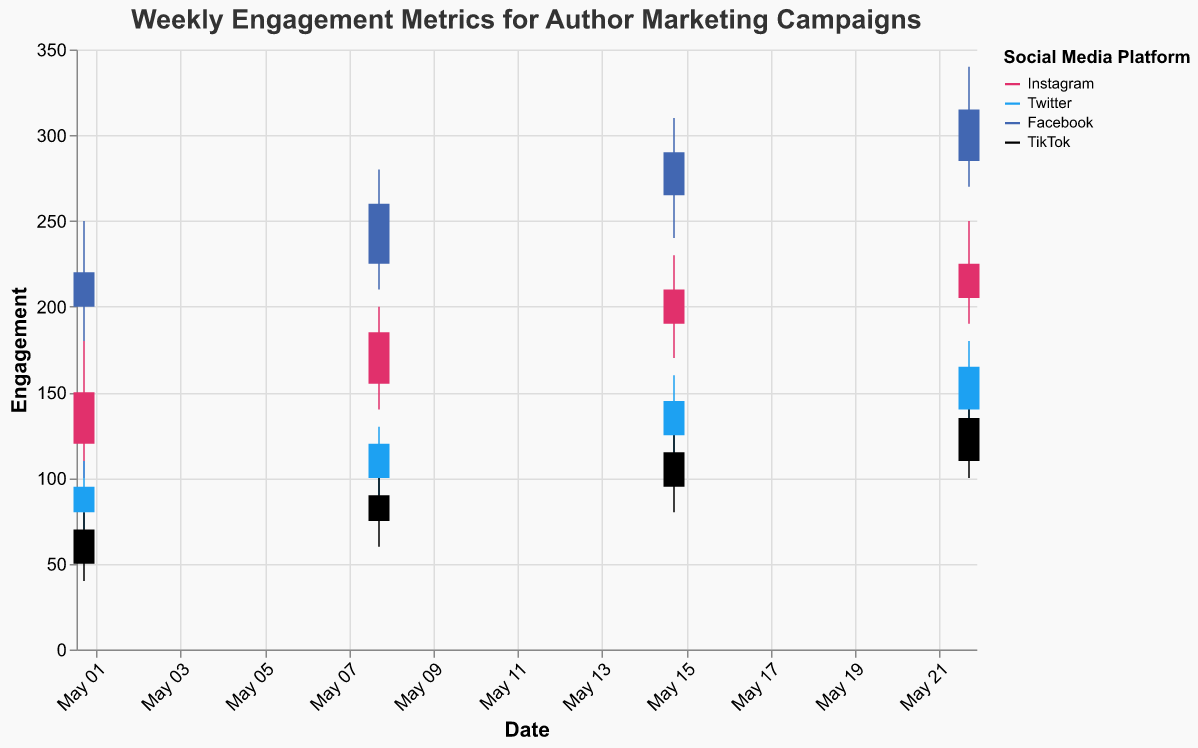What's the engagement range on Instagram for the week of May 8, 2023? To find the engagement range, subtract the Low value from the High value for the specified week. Here, the High value is 200 and the Low value is 140. So, 200 - 140 = 60.
Answer: 60 Which social media platform had the highest engagement on May 22, 2023? Look for the highest High value on May 22, 2023. The High values for Instagram, Twitter, Facebook, and TikTok are 250, 180, 340, and 150 respectively. Facebook has the highest value at 340.
Answer: Facebook What was the closing engagement on Twitter on May 15, 2023? Locate the Close value for Twitter on May 15, 2023. The Close value is 145.
Answer: 145 Which week shows the highest increase in closing engagement for Instagram? Calculate the difference in Close values week by week for Instagram. The differences are: (185-150) = 35, (210-185) = 25, (225-210) = 15. The highest increase is from 150 to 185 (35).
Answer: May 8, 2023 Compare the engagement trends between Instagram and TikTok. Which platform had a more consistent increase? Evaluate the Open and Close values across the weeks for both platforms. Instagram's Close values increase consistently each week (150, 185, 210, 225), while TikTok's Close values also increase consistently though with smaller increments (70, 90, 115, 135). Both platforms show consistent increases, but Instagram's increments are larger.
Answer: Instagram Which platform had the lowest opening engagement on May 1, 2023? Look for the lowest Open value among the platforms on May 1, 2023. The Open values are Instagram 120, Twitter 80, Facebook 200, TikTok 50. TikTok has the lowest value at 50.
Answer: TikTok For the week of May 15, 2023, which platform had the highest volatility in engagement? Volatility can be calculated as (High - Low). For May 15, 2023, Instagram: (230-170)=60, Twitter: (160-110)=50, Facebook: (310-240)=70, TikTok: (130-80)=50. Facebook had the highest volatility at 70.
Answer: Facebook What is the overall trend in the engagement for Facebook throughout May 2023? Observe the High values for Facebook week by week: 250, 280, 310, 340. The values are steadily increasing each week, indicating a positive trend in engagement.
Answer: Increasing Which social media platform showed the least engagement on average in May 2023? Calculate the average Close values for each platform. Instagram: 150, 185, 210, 225; Twitter: 95, 120, 145, 165; Facebook: 220, 260, 290, 315; TikTok: 70, 90, 115, 135. The averages: Instagram (192.5), Twitter (131.25), Facebook (271.25), TikTok (102.5). TikTok has the lowest average engagement (102.5).
Answer: TikTok Which platform experienced the highest single-week rise in engagement from Open to Close in May 2023? Calculate the difference between Open and Close values for each week across all platforms. The highest single-week rise will be the maximum of these differences. Instagram: (150-120)=30, (185-155)=30, (210-190)=20, (225-205)=20; Twitter: (95-80)=15, (120-100)=20, (145-125)=20, (165-140)=25; Facebook: (220-200)=20, (260-225)=35, (290-265)=25, (315-285)=30; TikTok: (70-50)=20, (90-75)=15, (115-95)=20, (135-110)=25. The highest is Facebook's (260-225)=35.
Answer: Facebook 